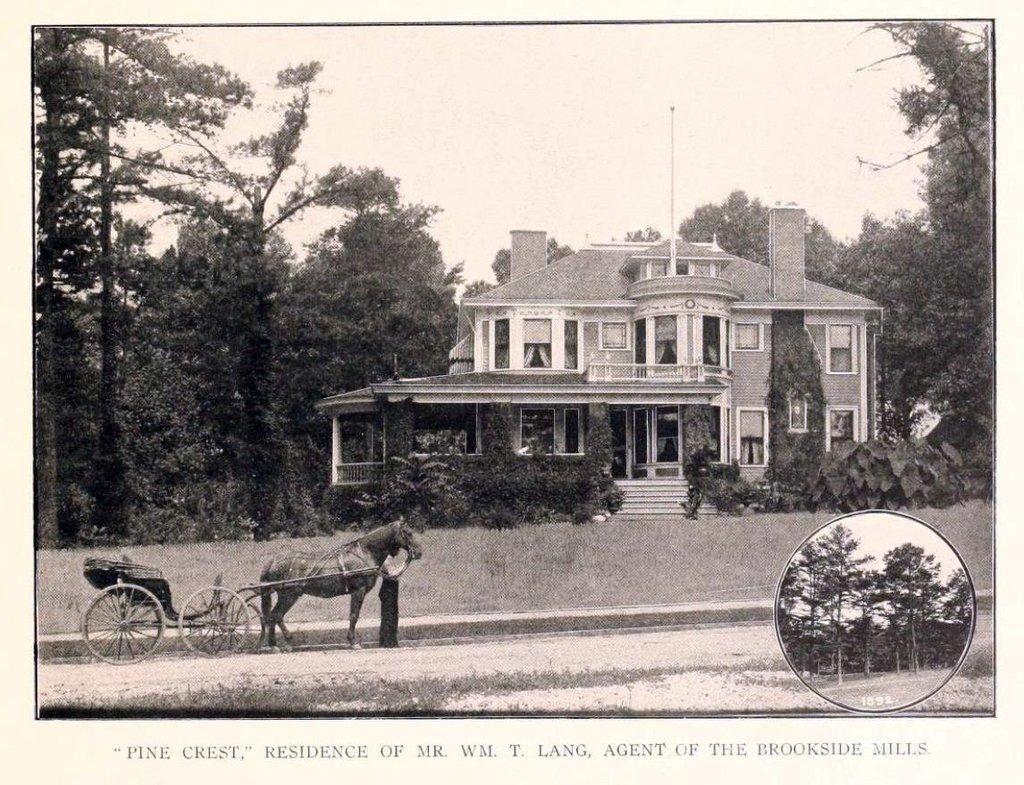Describe this image in one or two sentences. This is a black and white image. In the center of the image we can see building. On the right and left side of the image we can see trees. At the bottom there is a horse cart and text. In the background there is a sky. 